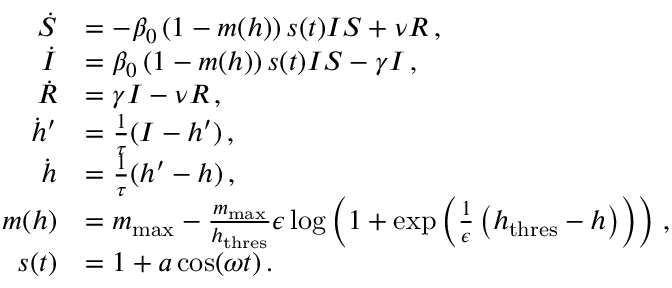Convert formula to latex. <formula><loc_0><loc_0><loc_500><loc_500>\begin{array} { r l } { \dot { S } } & { = - \beta _ { 0 } \left ( 1 - m ( h ) \right ) s ( t ) I S + \nu R \, , } \\ { \dot { I } } & { = \beta _ { 0 } \left ( 1 - m ( h ) \right ) s ( t ) I S - \gamma I \, , } \\ { \dot { R } } & { = \gamma I - \nu R \, , } \\ { \dot { h } ^ { \prime } } & { = \frac { 1 } { \tau } ( I - h ^ { \prime } ) \, , } \\ { \dot { h } } & { = \frac { 1 } { \tau } ( h ^ { \prime } - h ) \, , } \\ { m ( h ) } & { = m _ { \max } - \frac { m _ { \max } } { h _ { t h r e s } } \epsilon \log \left ( 1 + \exp \left ( \frac { 1 } { \epsilon } \left ( h _ { t h r e s } - h \right ) \right ) \right ) \, , } \\ { s ( t ) } & { = 1 + a \, \cos ( \omega t ) \, . } \end{array}</formula> 